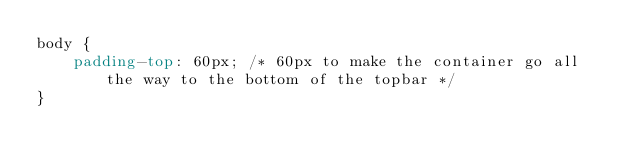Convert code to text. <code><loc_0><loc_0><loc_500><loc_500><_CSS_>body {
    padding-top: 60px; /* 60px to make the container go all the way to the bottom of the topbar */
}</code> 